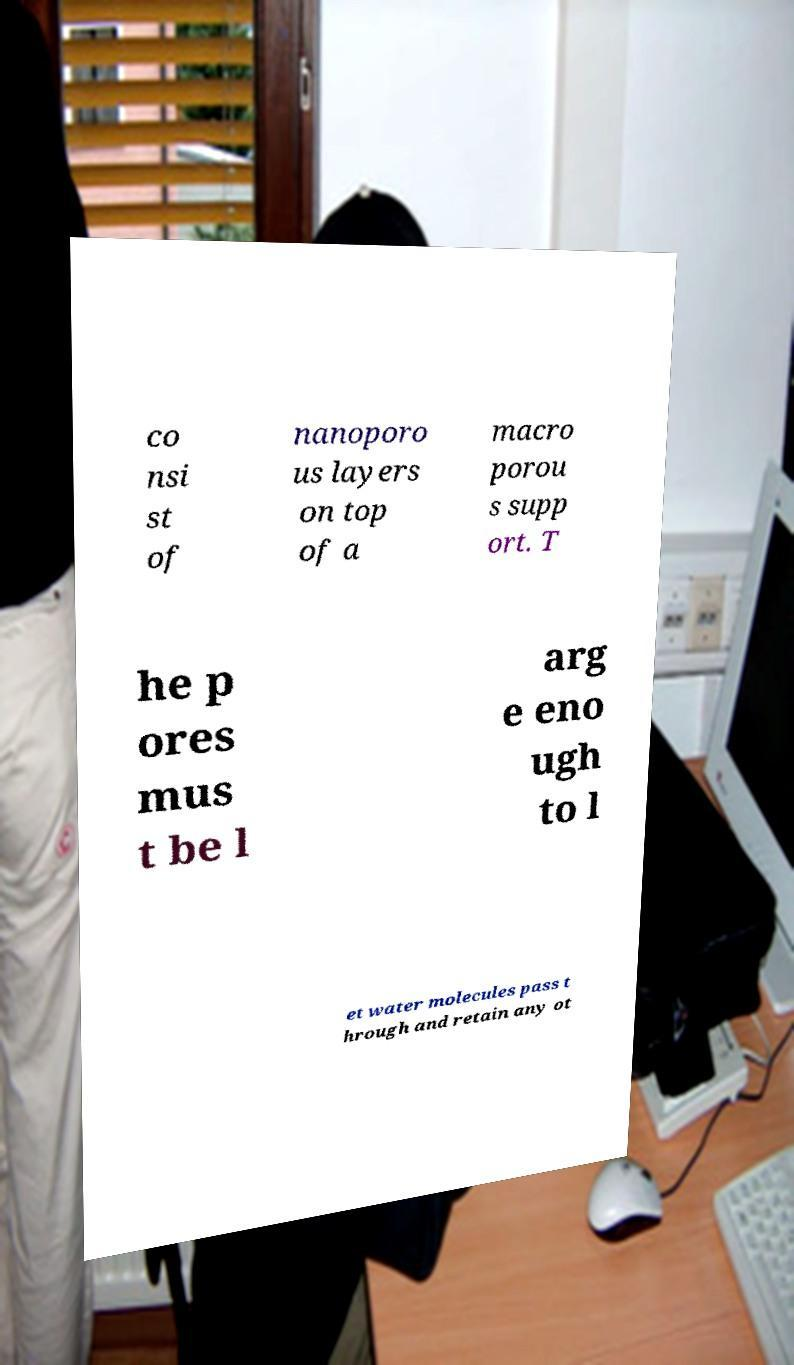Can you accurately transcribe the text from the provided image for me? co nsi st of nanoporo us layers on top of a macro porou s supp ort. T he p ores mus t be l arg e eno ugh to l et water molecules pass t hrough and retain any ot 